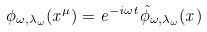Convert formula to latex. <formula><loc_0><loc_0><loc_500><loc_500>\phi _ { \omega , \lambda _ { \omega } } ( x ^ { \mu } ) = e ^ { - i \omega t } \tilde { \phi } _ { \omega , \lambda _ { \omega } } ( x )</formula> 